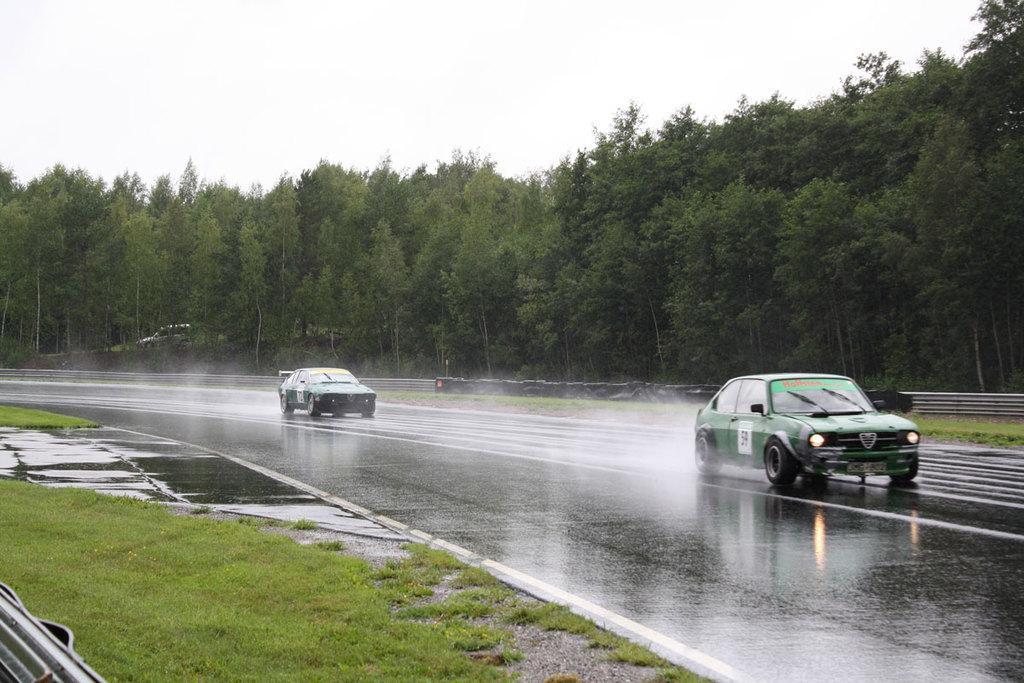How would you summarize this image in a sentence or two? In this image I can see the road, 2 cars on the road, some grass on the ground, some water on the road and the railing. In the background I can see few trees, a car and the sky. 